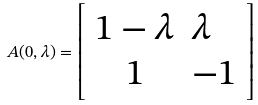Convert formula to latex. <formula><loc_0><loc_0><loc_500><loc_500>A ( 0 , \lambda ) = \left [ \begin{array} { c l c r } 1 - \lambda & \lambda \\ 1 & - 1 \end{array} \right ]</formula> 